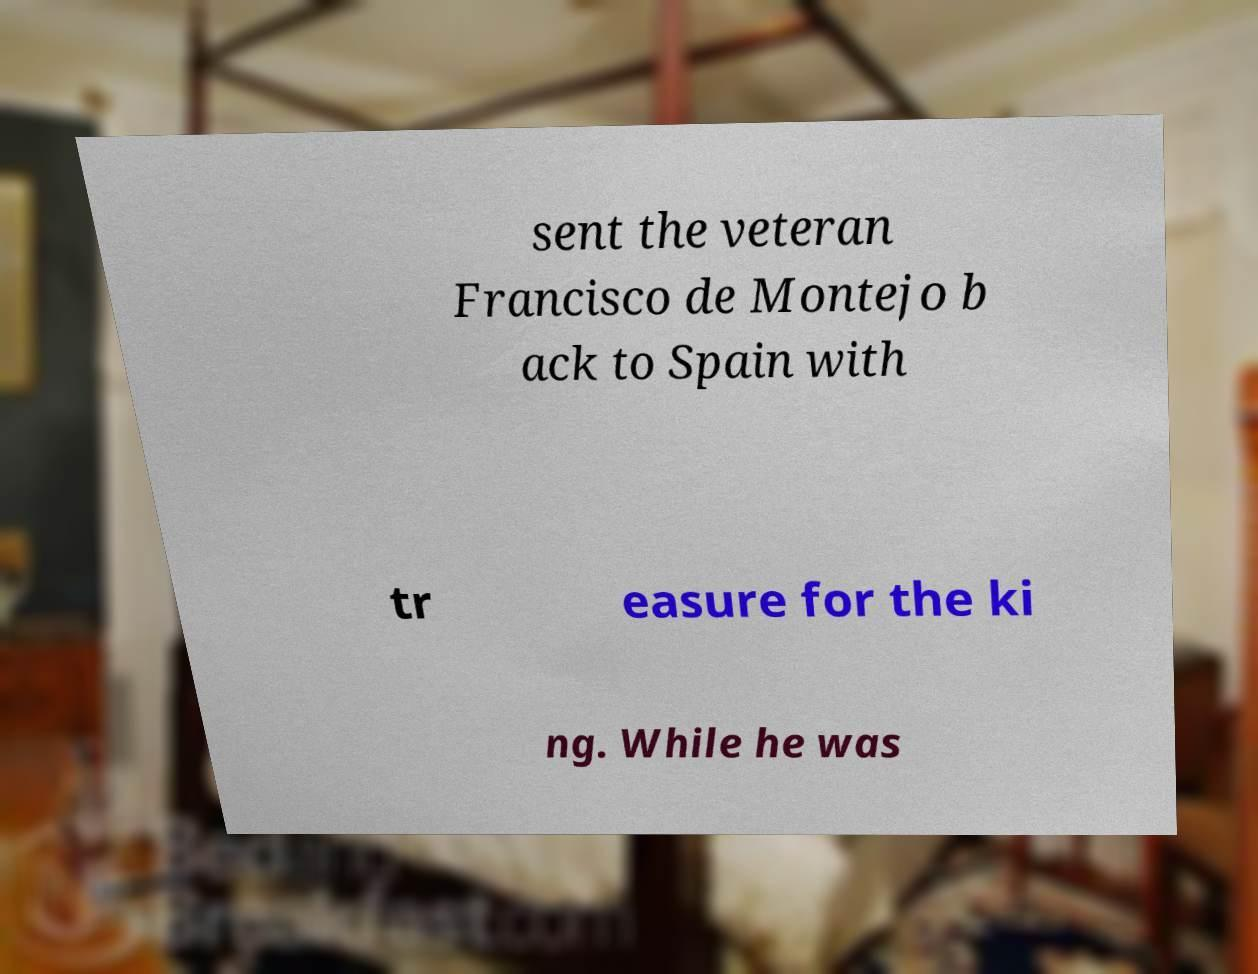Could you assist in decoding the text presented in this image and type it out clearly? sent the veteran Francisco de Montejo b ack to Spain with tr easure for the ki ng. While he was 